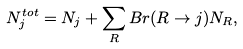Convert formula to latex. <formula><loc_0><loc_0><loc_500><loc_500>N _ { j } ^ { t o t } = N _ { j } + \sum _ { R } B r ( R \rightarrow j ) N _ { R } ,</formula> 